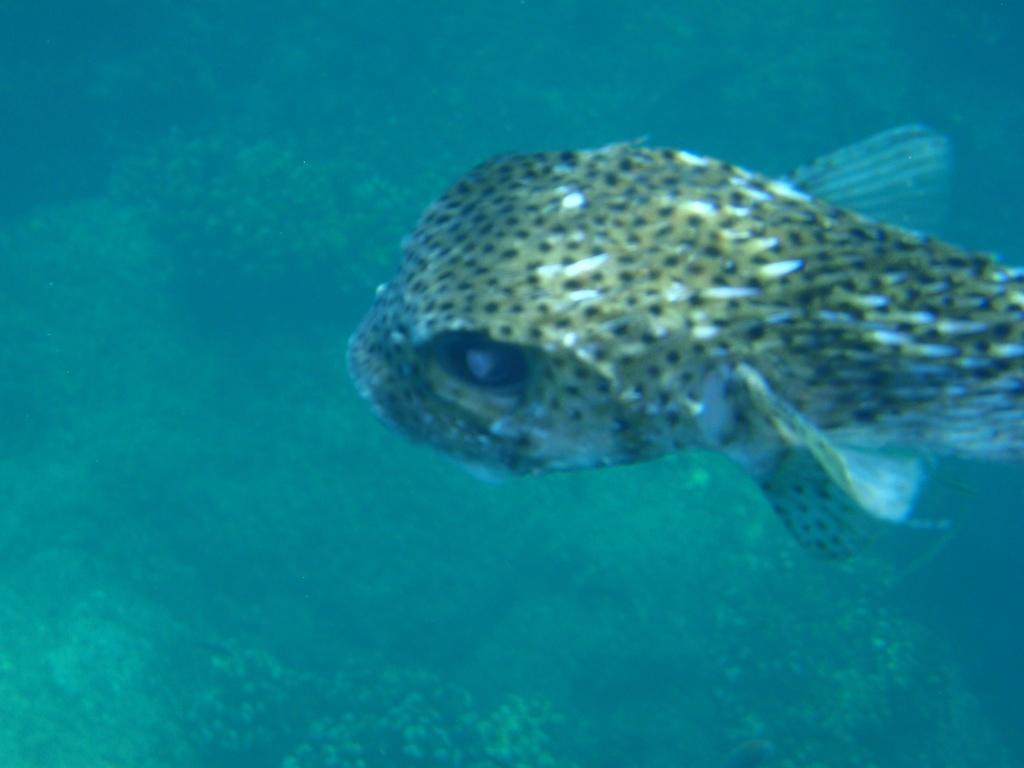What type of animal is in the image? There is a fish in the image. What else can be seen in the water with the fish? Aquatic plants are present in the water in the image. What sound does the coil make in the image? There is no coil present in the image, so it cannot make any sound. 